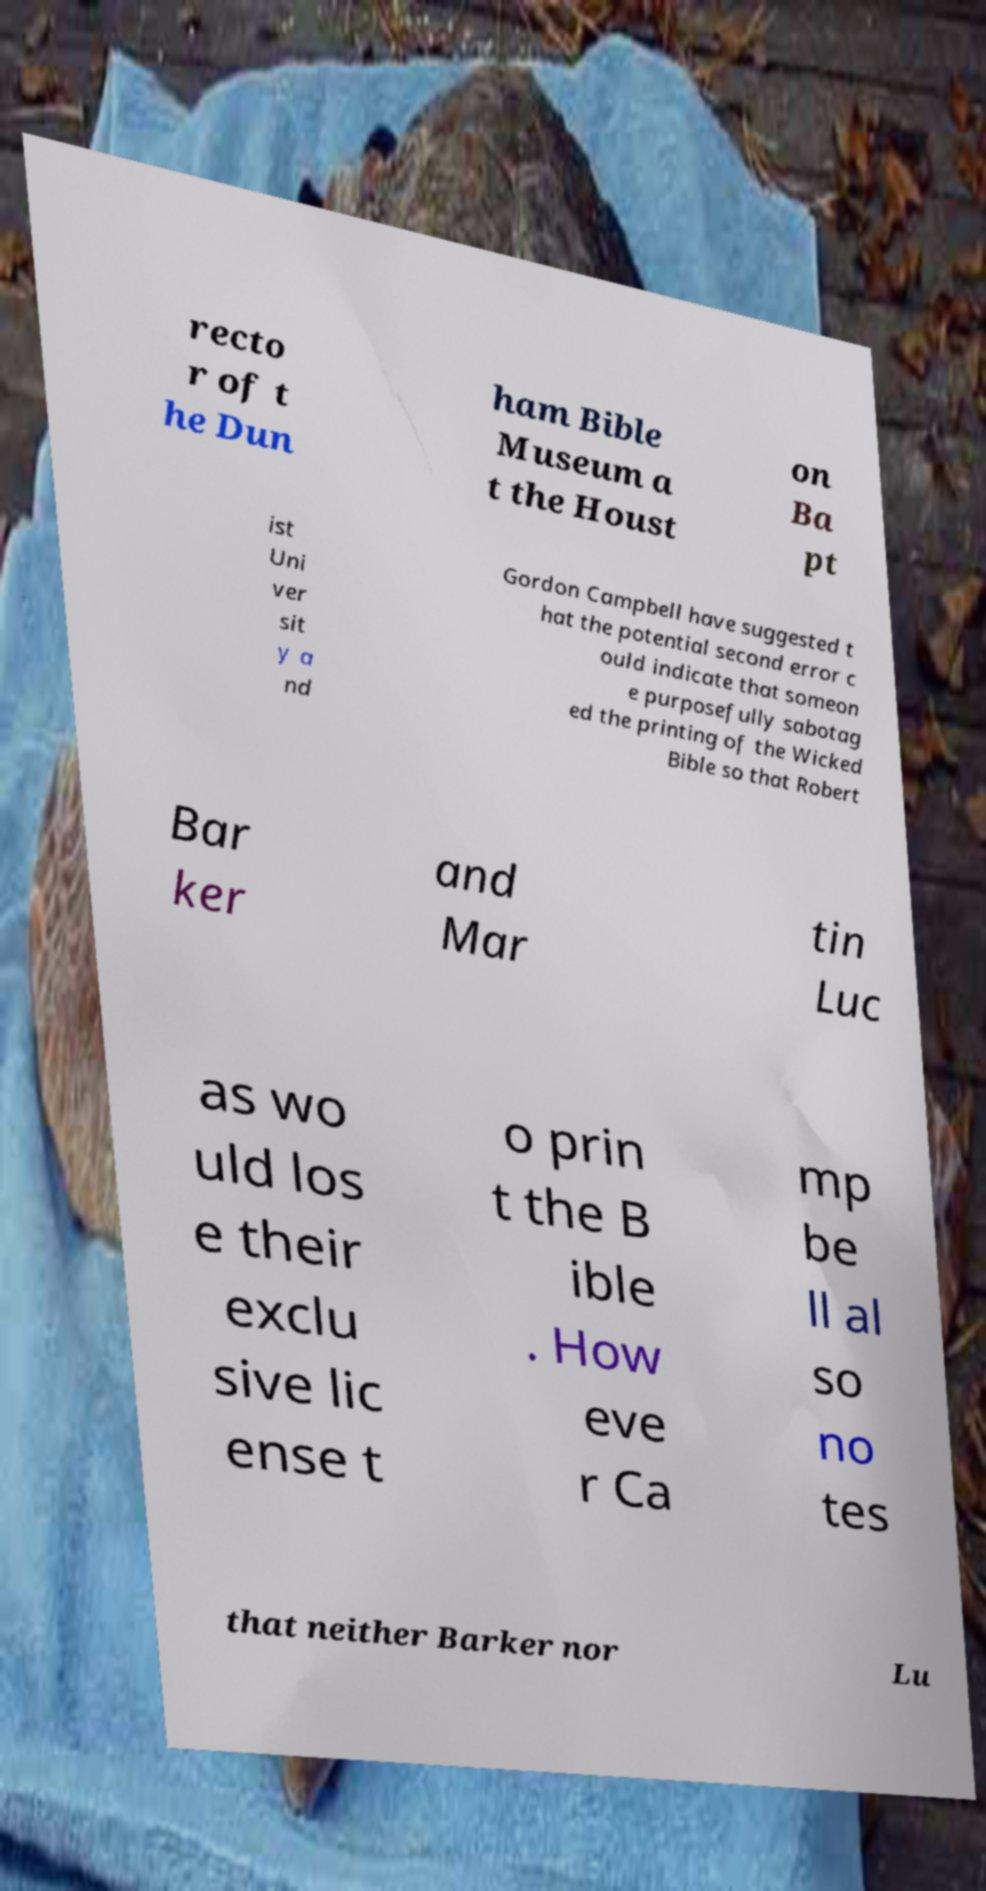Can you accurately transcribe the text from the provided image for me? recto r of t he Dun ham Bible Museum a t the Houst on Ba pt ist Uni ver sit y a nd Gordon Campbell have suggested t hat the potential second error c ould indicate that someon e purposefully sabotag ed the printing of the Wicked Bible so that Robert Bar ker and Mar tin Luc as wo uld los e their exclu sive lic ense t o prin t the B ible . How eve r Ca mp be ll al so no tes that neither Barker nor Lu 